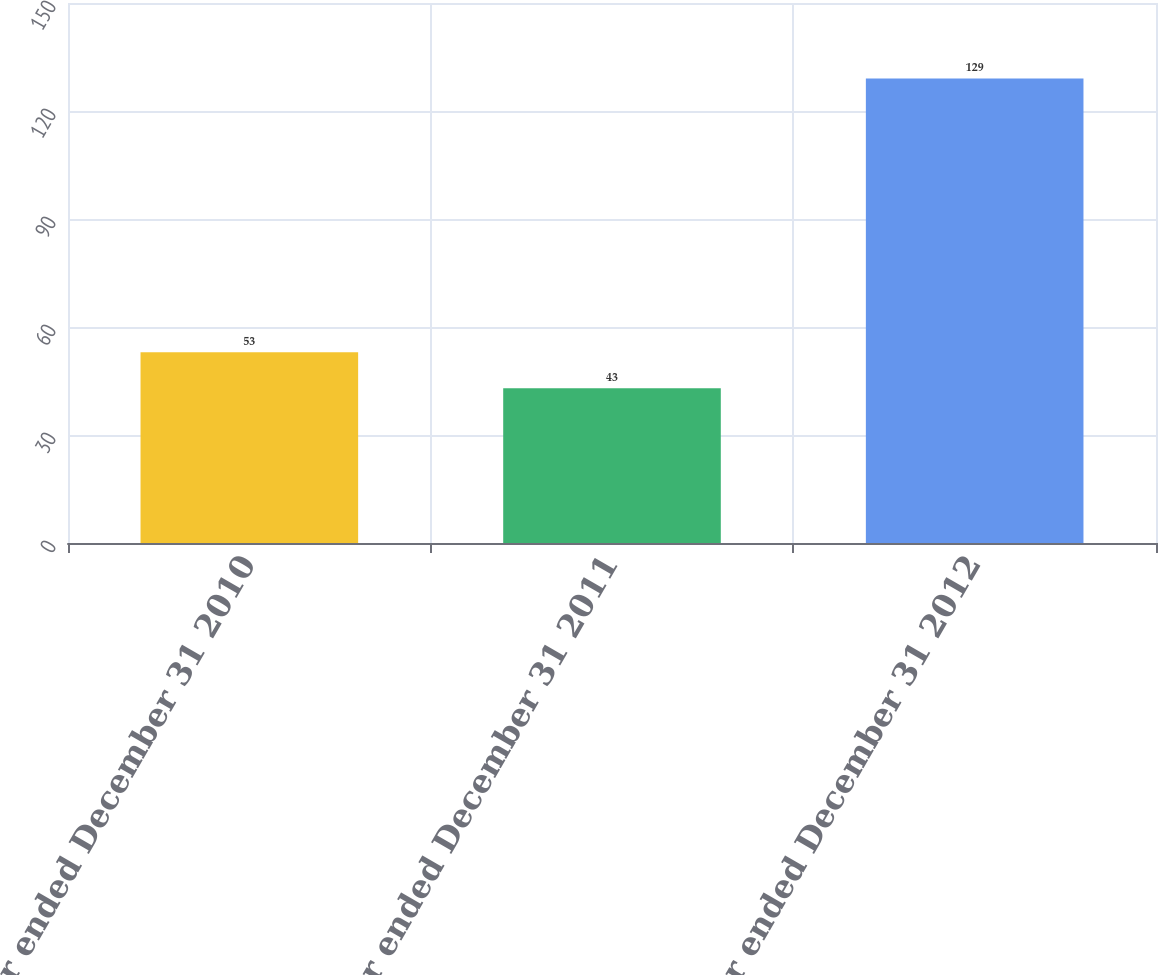Convert chart to OTSL. <chart><loc_0><loc_0><loc_500><loc_500><bar_chart><fcel>Year ended December 31 2010<fcel>Year ended December 31 2011<fcel>Year ended December 31 2012<nl><fcel>53<fcel>43<fcel>129<nl></chart> 